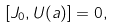Convert formula to latex. <formula><loc_0><loc_0><loc_500><loc_500>[ J _ { 0 } , U ( a ) ] = 0 ,</formula> 